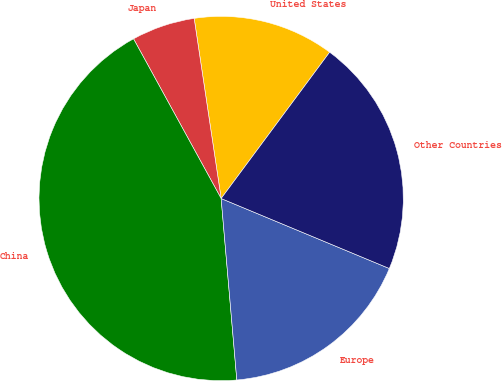Convert chart. <chart><loc_0><loc_0><loc_500><loc_500><pie_chart><fcel>United States<fcel>Japan<fcel>China<fcel>Europe<fcel>Other Countries<nl><fcel>12.52%<fcel>5.62%<fcel>43.38%<fcel>17.35%<fcel>21.12%<nl></chart> 